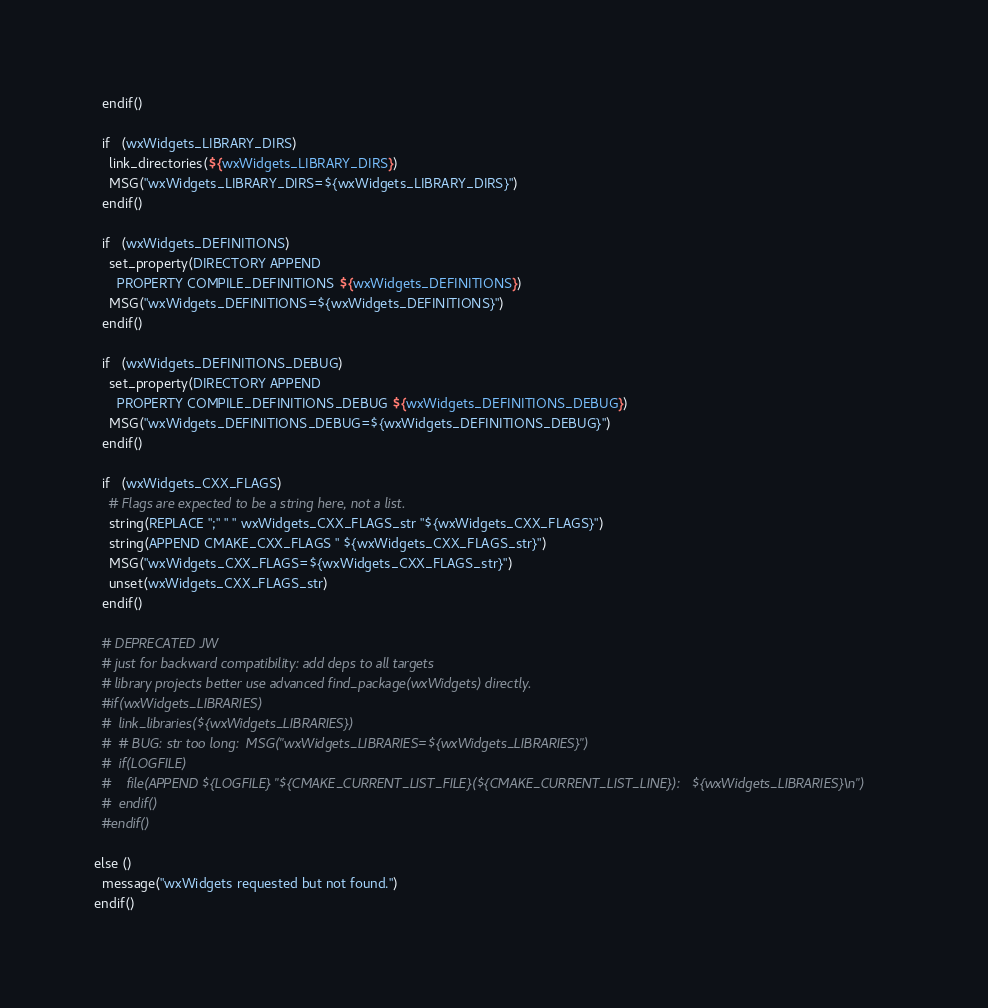Convert code to text. <code><loc_0><loc_0><loc_500><loc_500><_CMake_>  endif()

  if   (wxWidgets_LIBRARY_DIRS)
    link_directories(${wxWidgets_LIBRARY_DIRS})
    MSG("wxWidgets_LIBRARY_DIRS=${wxWidgets_LIBRARY_DIRS}")
  endif()

  if   (wxWidgets_DEFINITIONS)
    set_property(DIRECTORY APPEND
      PROPERTY COMPILE_DEFINITIONS ${wxWidgets_DEFINITIONS})
    MSG("wxWidgets_DEFINITIONS=${wxWidgets_DEFINITIONS}")
  endif()

  if   (wxWidgets_DEFINITIONS_DEBUG)
    set_property(DIRECTORY APPEND
      PROPERTY COMPILE_DEFINITIONS_DEBUG ${wxWidgets_DEFINITIONS_DEBUG})
    MSG("wxWidgets_DEFINITIONS_DEBUG=${wxWidgets_DEFINITIONS_DEBUG}")
  endif()

  if   (wxWidgets_CXX_FLAGS)
    # Flags are expected to be a string here, not a list.
    string(REPLACE ";" " " wxWidgets_CXX_FLAGS_str "${wxWidgets_CXX_FLAGS}")
    string(APPEND CMAKE_CXX_FLAGS " ${wxWidgets_CXX_FLAGS_str}")
    MSG("wxWidgets_CXX_FLAGS=${wxWidgets_CXX_FLAGS_str}")
    unset(wxWidgets_CXX_FLAGS_str)
  endif()

  # DEPRECATED JW
  # just for backward compatibility: add deps to all targets
  # library projects better use advanced find_package(wxWidgets) directly.
  #if(wxWidgets_LIBRARIES)
  #  link_libraries(${wxWidgets_LIBRARIES})
  #  # BUG: str too long:  MSG("wxWidgets_LIBRARIES=${wxWidgets_LIBRARIES}")
  #  if(LOGFILE)
  #    file(APPEND ${LOGFILE} "${CMAKE_CURRENT_LIST_FILE}(${CMAKE_CURRENT_LIST_LINE}):   ${wxWidgets_LIBRARIES}\n")
  #  endif()
  #endif()

else ()
  message("wxWidgets requested but not found.")
endif()
</code> 